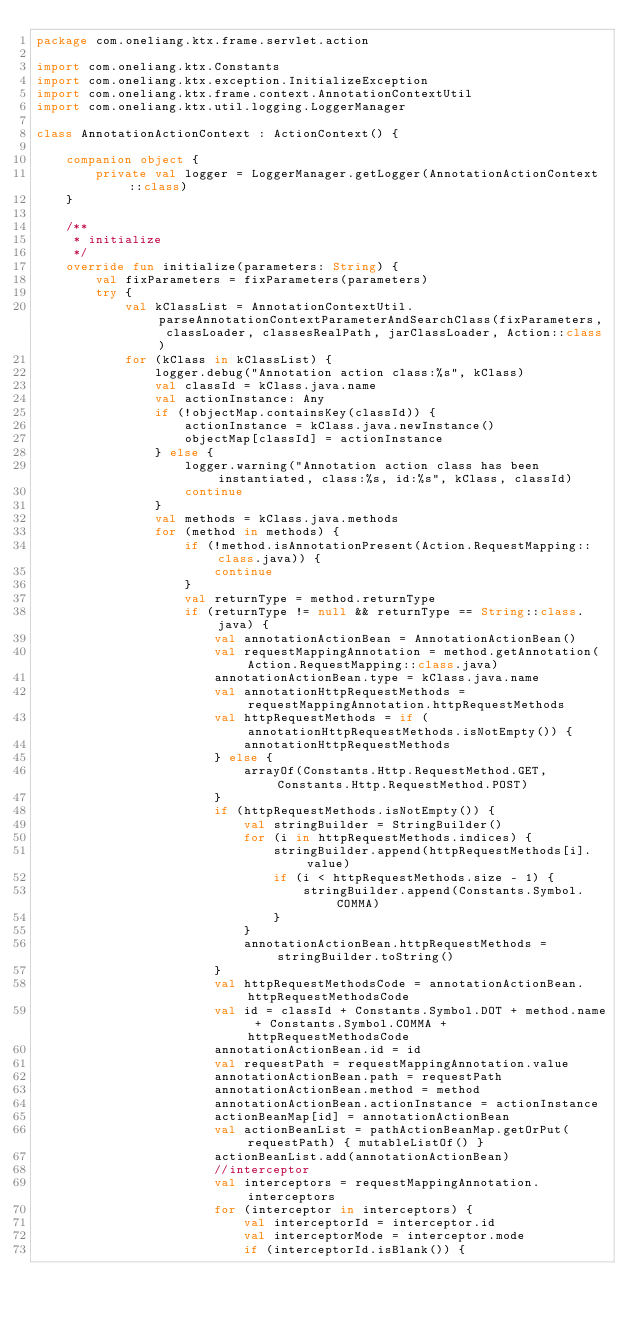<code> <loc_0><loc_0><loc_500><loc_500><_Kotlin_>package com.oneliang.ktx.frame.servlet.action

import com.oneliang.ktx.Constants
import com.oneliang.ktx.exception.InitializeException
import com.oneliang.ktx.frame.context.AnnotationContextUtil
import com.oneliang.ktx.util.logging.LoggerManager

class AnnotationActionContext : ActionContext() {

    companion object {
        private val logger = LoggerManager.getLogger(AnnotationActionContext::class)
    }

    /**
     * initialize
     */
    override fun initialize(parameters: String) {
        val fixParameters = fixParameters(parameters)
        try {
            val kClassList = AnnotationContextUtil.parseAnnotationContextParameterAndSearchClass(fixParameters, classLoader, classesRealPath, jarClassLoader, Action::class)
            for (kClass in kClassList) {
                logger.debug("Annotation action class:%s", kClass)
                val classId = kClass.java.name
                val actionInstance: Any
                if (!objectMap.containsKey(classId)) {
                    actionInstance = kClass.java.newInstance()
                    objectMap[classId] = actionInstance
                } else {
                    logger.warning("Annotation action class has been instantiated, class:%s, id:%s", kClass, classId)
                    continue
                }
                val methods = kClass.java.methods
                for (method in methods) {
                    if (!method.isAnnotationPresent(Action.RequestMapping::class.java)) {
                        continue
                    }
                    val returnType = method.returnType
                    if (returnType != null && returnType == String::class.java) {
                        val annotationActionBean = AnnotationActionBean()
                        val requestMappingAnnotation = method.getAnnotation(Action.RequestMapping::class.java)
                        annotationActionBean.type = kClass.java.name
                        val annotationHttpRequestMethods = requestMappingAnnotation.httpRequestMethods
                        val httpRequestMethods = if (annotationHttpRequestMethods.isNotEmpty()) {
                            annotationHttpRequestMethods
                        } else {
                            arrayOf(Constants.Http.RequestMethod.GET, Constants.Http.RequestMethod.POST)
                        }
                        if (httpRequestMethods.isNotEmpty()) {
                            val stringBuilder = StringBuilder()
                            for (i in httpRequestMethods.indices) {
                                stringBuilder.append(httpRequestMethods[i].value)
                                if (i < httpRequestMethods.size - 1) {
                                    stringBuilder.append(Constants.Symbol.COMMA)
                                }
                            }
                            annotationActionBean.httpRequestMethods = stringBuilder.toString()
                        }
                        val httpRequestMethodsCode = annotationActionBean.httpRequestMethodsCode
                        val id = classId + Constants.Symbol.DOT + method.name + Constants.Symbol.COMMA + httpRequestMethodsCode
                        annotationActionBean.id = id
                        val requestPath = requestMappingAnnotation.value
                        annotationActionBean.path = requestPath
                        annotationActionBean.method = method
                        annotationActionBean.actionInstance = actionInstance
                        actionBeanMap[id] = annotationActionBean
                        val actionBeanList = pathActionBeanMap.getOrPut(requestPath) { mutableListOf() }
                        actionBeanList.add(annotationActionBean)
                        //interceptor
                        val interceptors = requestMappingAnnotation.interceptors
                        for (interceptor in interceptors) {
                            val interceptorId = interceptor.id
                            val interceptorMode = interceptor.mode
                            if (interceptorId.isBlank()) {</code> 